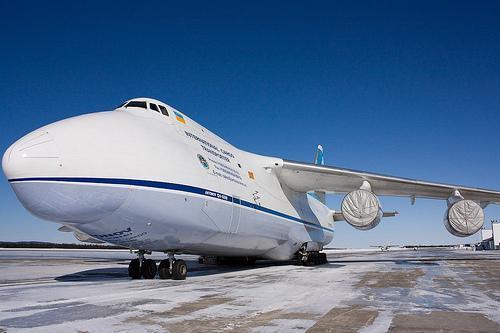How many planes are in the picture?
Give a very brief answer. 1. 